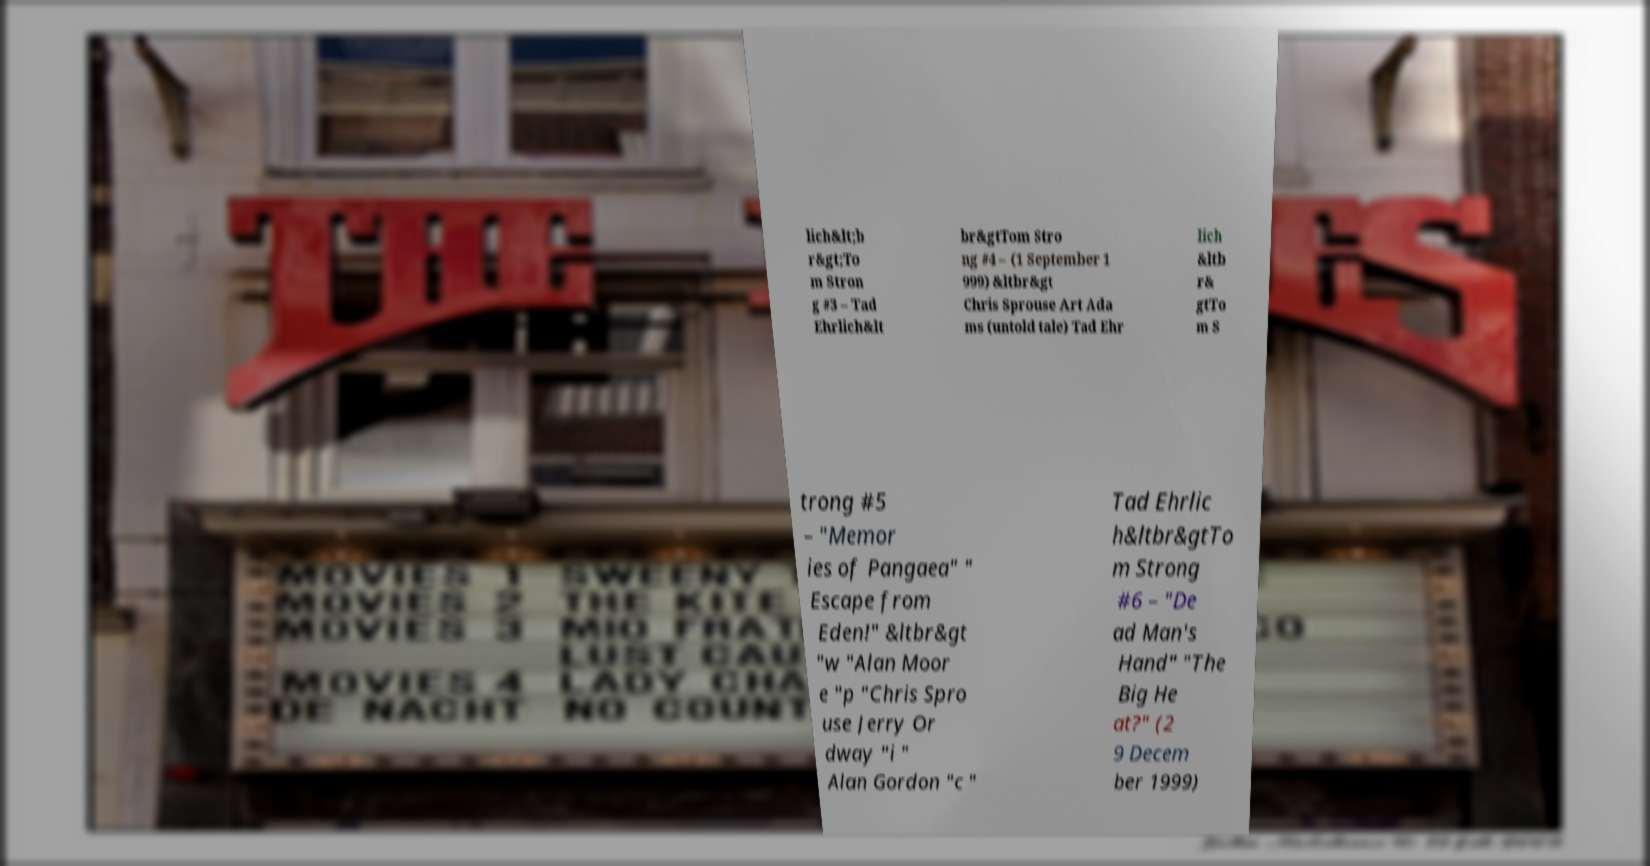Could you extract and type out the text from this image? lich&lt;b r&gt;To m Stron g #3 – Tad Ehrlich&lt br&gtTom Stro ng #4 – (1 September 1 999) &ltbr&gt Chris Sprouse Art Ada ms (untold tale) Tad Ehr lich &ltb r& gtTo m S trong #5 – "Memor ies of Pangaea" " Escape from Eden!" &ltbr&gt "w "Alan Moor e "p "Chris Spro use Jerry Or dway "i " Alan Gordon "c " Tad Ehrlic h&ltbr&gtTo m Strong #6 – "De ad Man's Hand" "The Big He at?" (2 9 Decem ber 1999) 